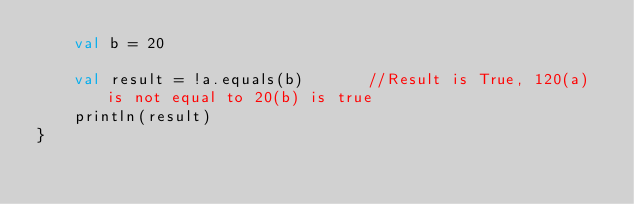Convert code to text. <code><loc_0><loc_0><loc_500><loc_500><_Kotlin_>    val b = 20

    val result = !a.equals(b)       //Result is True, 120(a) is not equal to 20(b) is true
    println(result)
}</code> 